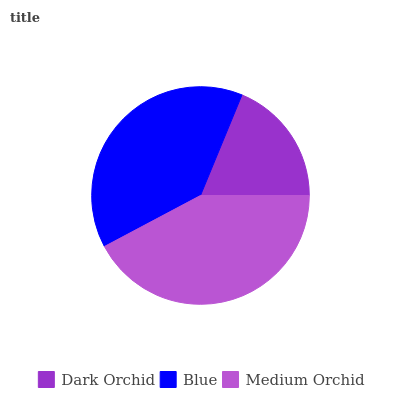Is Dark Orchid the minimum?
Answer yes or no. Yes. Is Medium Orchid the maximum?
Answer yes or no. Yes. Is Blue the minimum?
Answer yes or no. No. Is Blue the maximum?
Answer yes or no. No. Is Blue greater than Dark Orchid?
Answer yes or no. Yes. Is Dark Orchid less than Blue?
Answer yes or no. Yes. Is Dark Orchid greater than Blue?
Answer yes or no. No. Is Blue less than Dark Orchid?
Answer yes or no. No. Is Blue the high median?
Answer yes or no. Yes. Is Blue the low median?
Answer yes or no. Yes. Is Dark Orchid the high median?
Answer yes or no. No. Is Medium Orchid the low median?
Answer yes or no. No. 